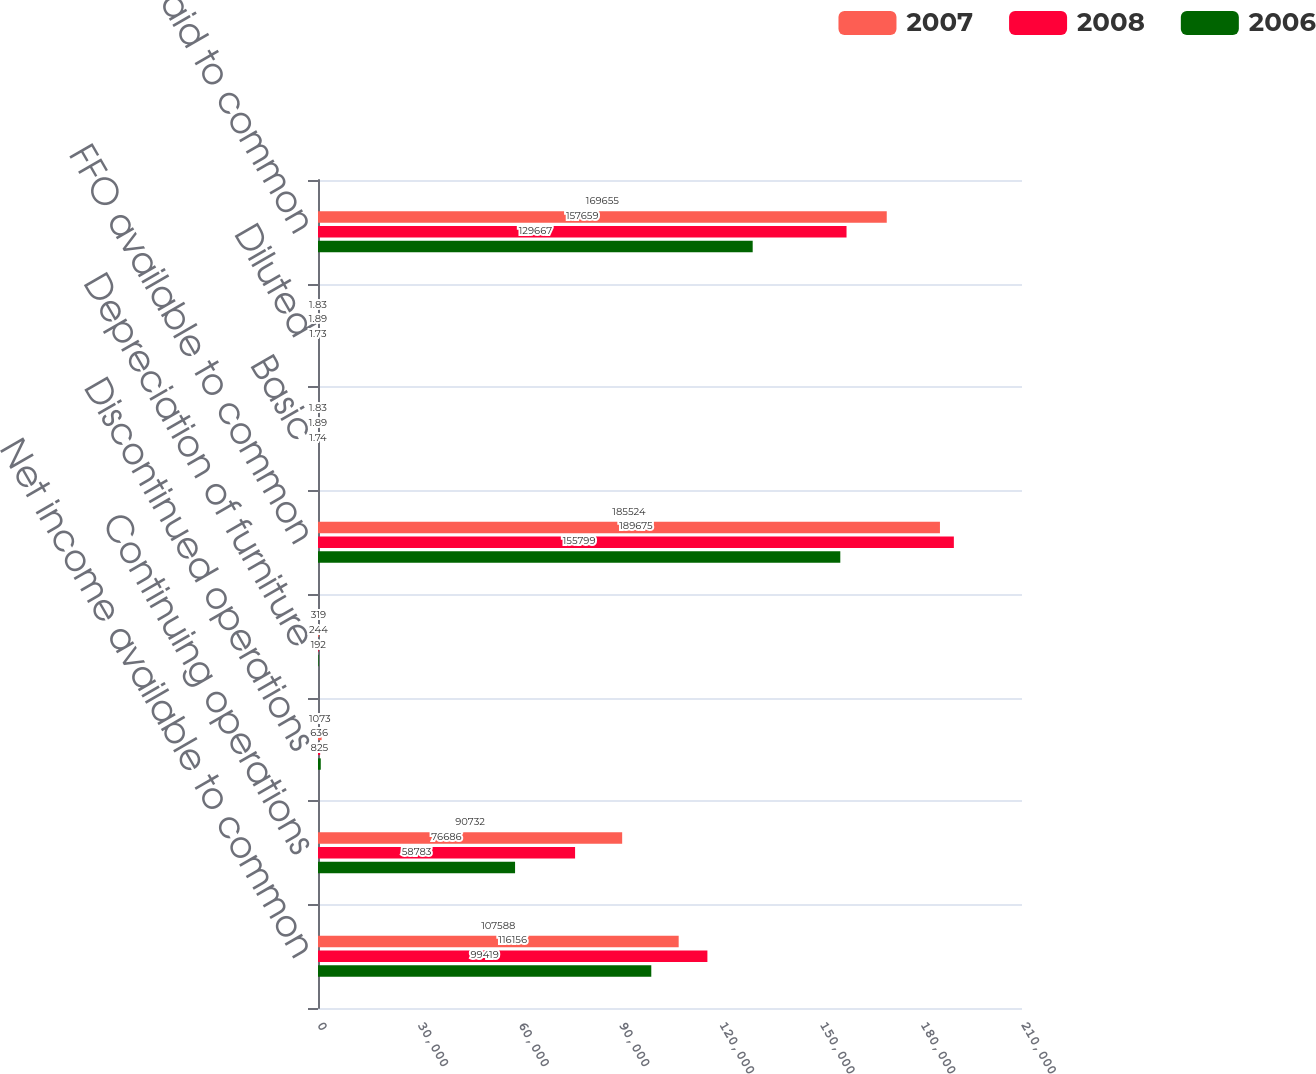Convert chart to OTSL. <chart><loc_0><loc_0><loc_500><loc_500><stacked_bar_chart><ecel><fcel>Net income available to common<fcel>Continuing operations<fcel>Discontinued operations<fcel>Depreciation of furniture<fcel>FFO available to common<fcel>Basic<fcel>Diluted<fcel>Distributions paid to common<nl><fcel>2007<fcel>107588<fcel>90732<fcel>1073<fcel>319<fcel>185524<fcel>1.83<fcel>1.83<fcel>169655<nl><fcel>2008<fcel>116156<fcel>76686<fcel>636<fcel>244<fcel>189675<fcel>1.89<fcel>1.89<fcel>157659<nl><fcel>2006<fcel>99419<fcel>58783<fcel>825<fcel>192<fcel>155799<fcel>1.74<fcel>1.73<fcel>129667<nl></chart> 